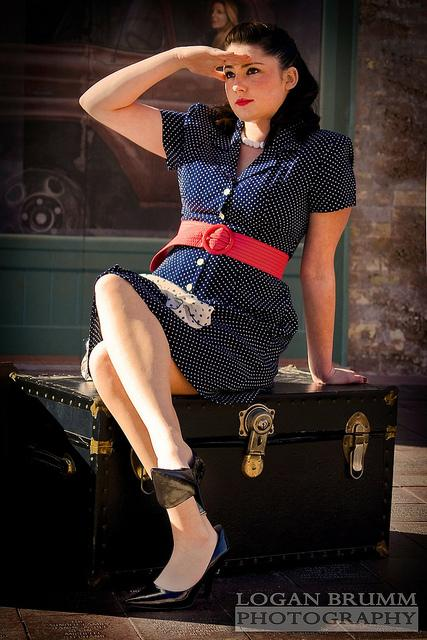What is usually held in the item being sat on here? Please explain your reasoning. clothing. The woman is sitting on a trunk, not a dog crate, bookcase, or gunny sack. 